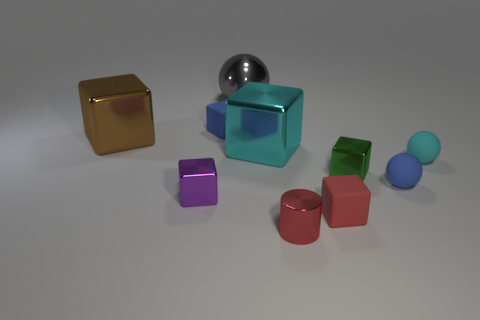What shape is the large cyan object?
Your answer should be compact. Cube. Does the big thing right of the gray metal object have the same material as the cube that is behind the big brown cube?
Offer a very short reply. No. There is a blue rubber thing to the right of the green cube; what is its shape?
Keep it short and to the point. Sphere. There is another matte thing that is the same shape as the small cyan rubber object; what is its size?
Offer a very short reply. Small. Is the cylinder the same color as the big shiny ball?
Your answer should be compact. No. Is there any other thing that has the same shape as the purple metal object?
Offer a terse response. Yes. Are there any shiny things in front of the large brown thing to the left of the tiny red block?
Provide a succinct answer. Yes. What color is the other matte object that is the same shape as the red matte object?
Provide a short and direct response. Blue. What number of balls have the same color as the small cylinder?
Keep it short and to the point. 0. There is a shiny cylinder that is in front of the rubber ball behind the blue object right of the gray object; what color is it?
Keep it short and to the point. Red. 